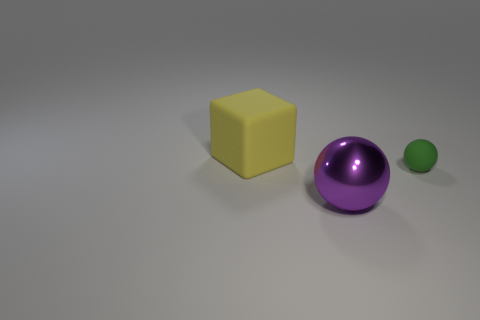Add 2 large purple metallic objects. How many objects exist? 5 Subtract all spheres. How many objects are left? 1 Subtract all big yellow rubber objects. Subtract all large cubes. How many objects are left? 1 Add 1 big purple things. How many big purple things are left? 2 Add 3 red rubber spheres. How many red rubber spheres exist? 3 Subtract 0 green cubes. How many objects are left? 3 Subtract all green balls. Subtract all brown blocks. How many balls are left? 1 